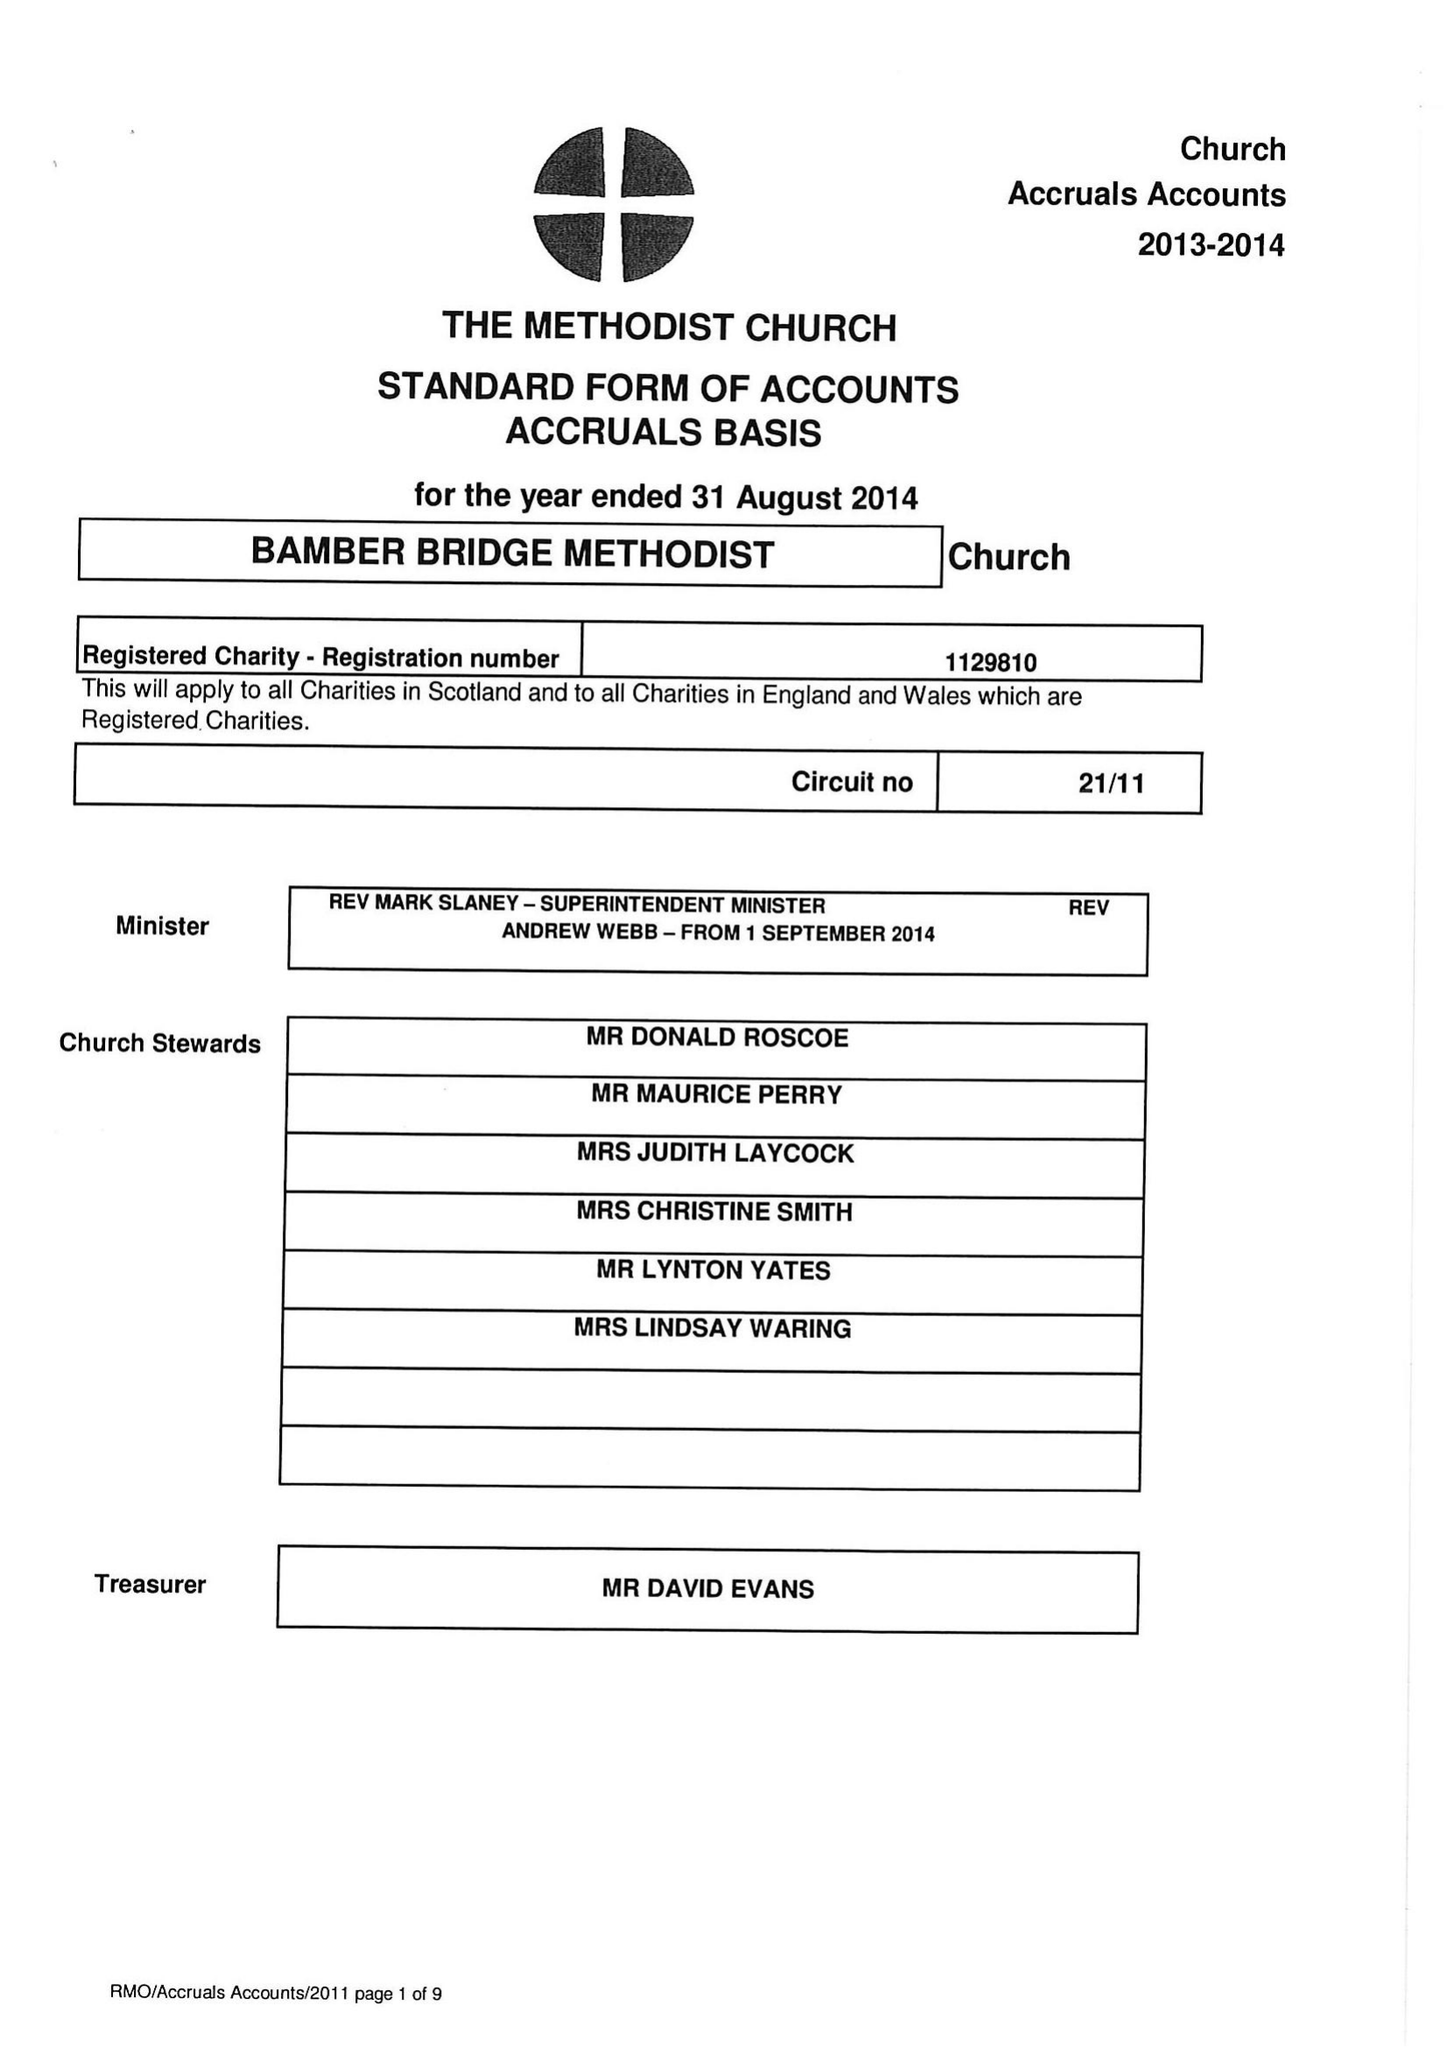What is the value for the address__post_town?
Answer the question using a single word or phrase. PRESTON 